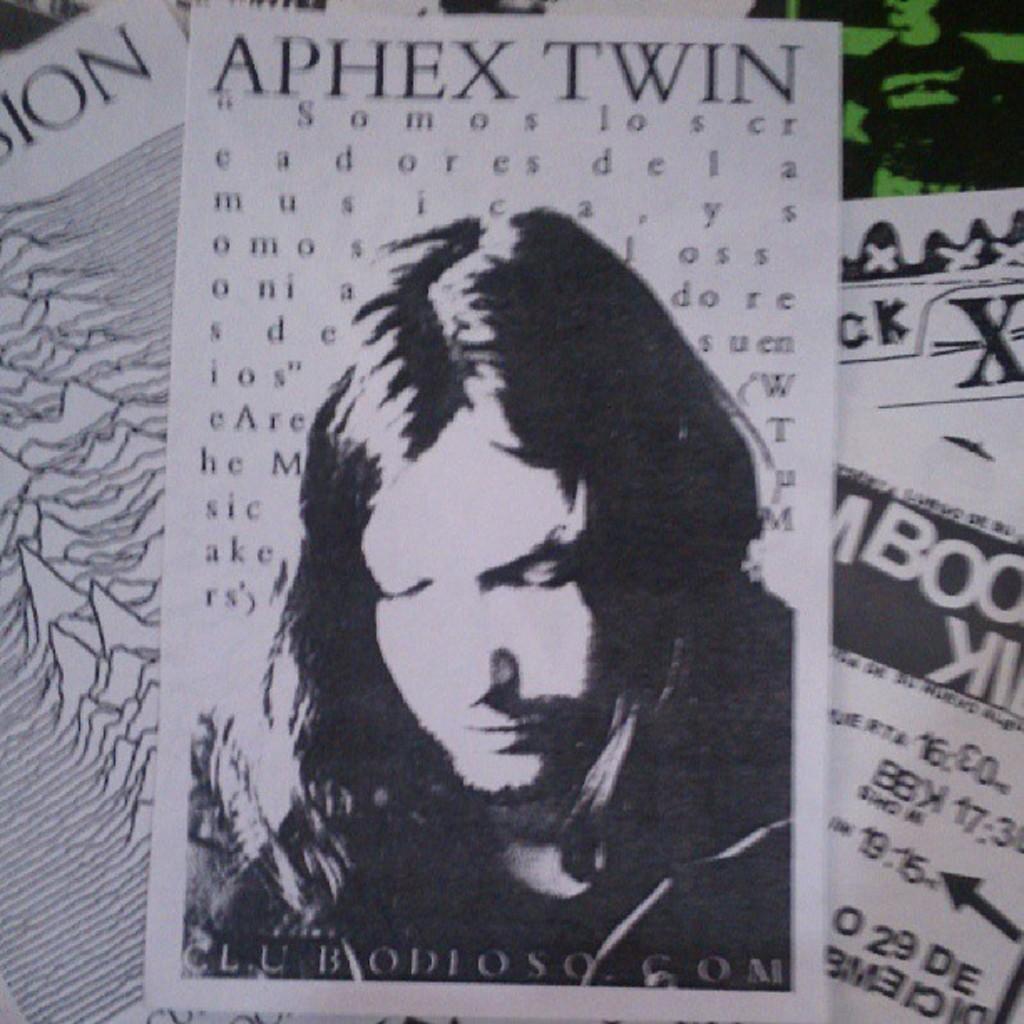Please provide a concise description of this image. There are papers. On the paper something is written. Also there is an image of a person. 